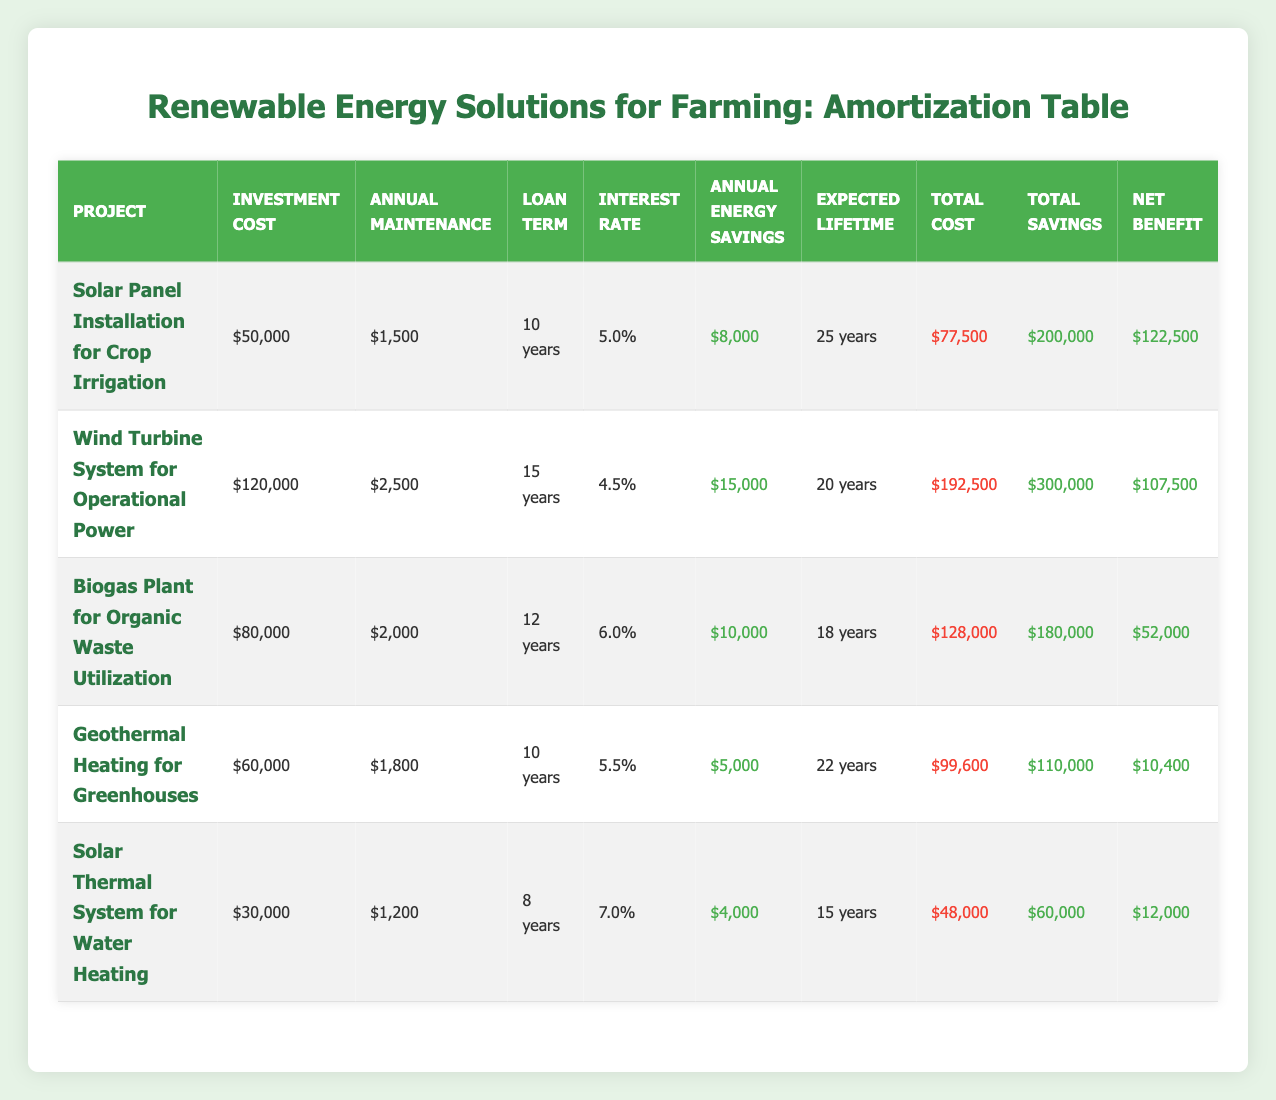What is the investment cost for the Wind Turbine System for Operational Power? The table shows that the investment cost for the Wind Turbine System for Operational Power is $120,000.
Answer: $120,000 What is the annual maintenance cost of the Solar Panel Installation for Crop Irrigation? The table indicates that the annual maintenance cost for the Solar Panel Installation for Crop Irrigation is $1,500.
Answer: $1,500 Which project has the longest loan term? By comparing the loan terms listed in the table, the Wind Turbine System for Operational Power has the longest loan term of 15 years.
Answer: 15 years What is the total cost of the Biogas Plant for Organic Waste Utilization? According to the table, the total cost for the Biogas Plant for Organic Waste Utilization is $128,000.
Answer: $128,000 Which project generates the highest annual energy savings? Reviewing the annual energy savings in the table, the Wind Turbine System for Operational Power generates the highest savings of $15,000.
Answer: $15,000 Is the net benefit of the Solar Thermal System for Water Heating positive? Looking at the net benefit for the Solar Thermal System for Water Heating in the table, it is noted as $12,000, which is positive.
Answer: Yes What is the average annual energy savings across all projects? First, we add the annual energy savings: $8,000 (Solar) + $15,000 (Wind) + $10,000 (Biogas) + $5,000 (Geothermal) + $4,000 (Solar Thermal) = $42,000. Then, we divide by the number of projects (5): $42,000 / 5 = $8,400.
Answer: $8,400 How much greater is the expected lifetime of the Solar Panel Installation for Crop Irrigation compared to the Solar Thermal System for Water Heating? The expected lifetime for the Solar Panel Installation is 25 years, and for the Solar Thermal System, it is 15 years. Therefore, the difference is 25 - 15 = 10 years.
Answer: 10 years Which project has the lowest annual maintenance cost? By comparing the annual maintenance costs from the table, the Solar Thermal System for Water Heating has the lowest maintenance cost of $1,200.
Answer: $1,200 